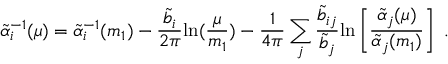Convert formula to latex. <formula><loc_0><loc_0><loc_500><loc_500>\tilde { \alpha } _ { i } ^ { - 1 } ( \mu ) = \tilde { \alpha } _ { i } ^ { - 1 } ( m _ { 1 } ) - { \frac { \tilde { b } _ { i } } { 2 \pi } } \ln ( { \frac { \mu } { m _ { 1 } } } ) - { \frac { 1 } { 4 \pi } } \sum _ { j } { \frac { \tilde { b } _ { i j } } { \tilde { b } _ { j } } } \ln \left [ { \frac { \tilde { \alpha } _ { j } ( \mu ) } { \tilde { \alpha } _ { j } ( m _ { 1 } ) } } \right ] .</formula> 